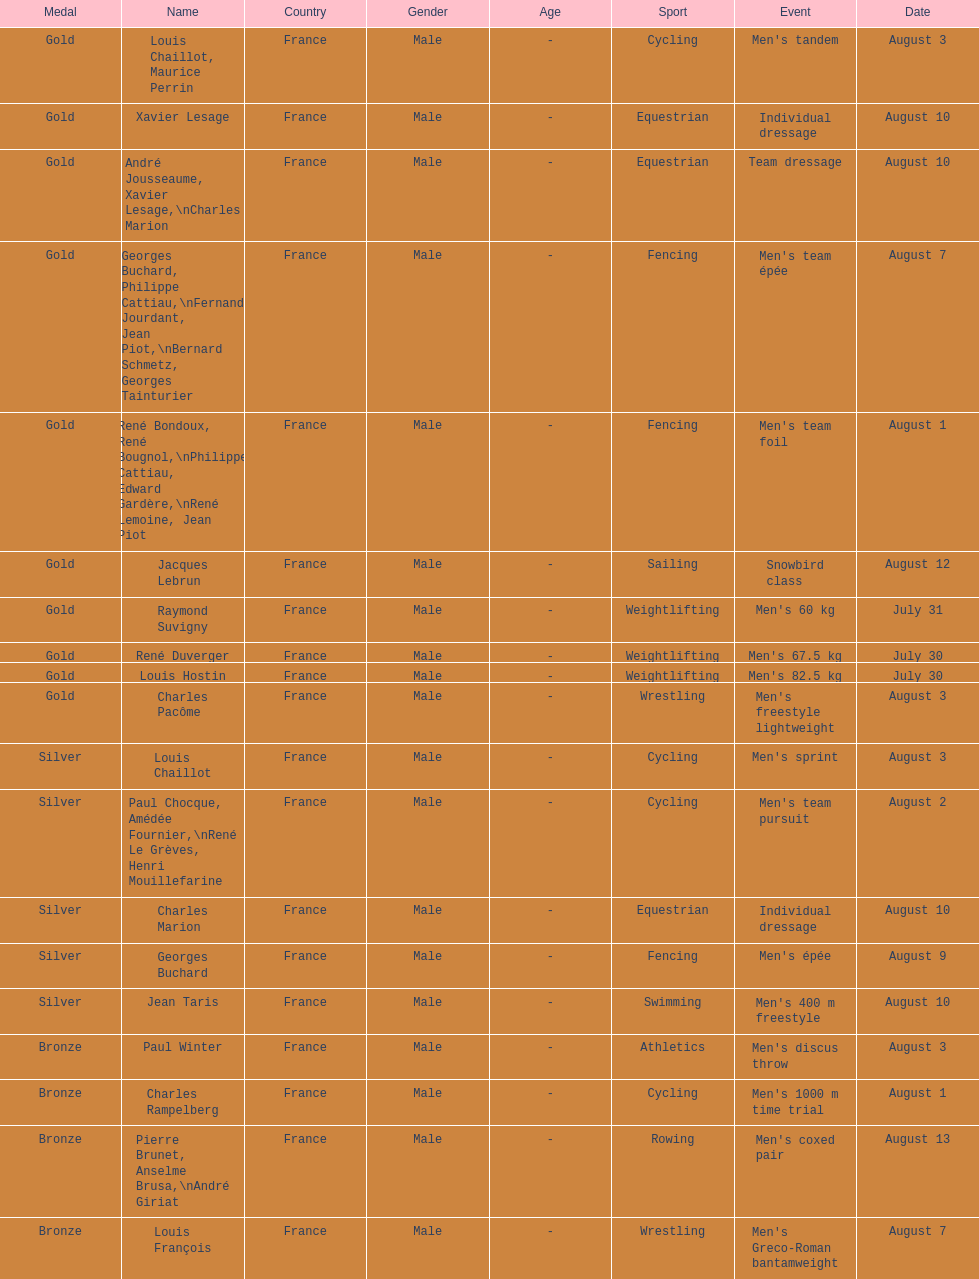What sport did louis challiot win the same medal as paul chocque in? Cycling. Parse the full table. {'header': ['Medal', 'Name', 'Country', 'Gender', 'Age', 'Sport', 'Event', 'Date'], 'rows': [['Gold', 'Louis Chaillot, Maurice Perrin', 'France', 'Male', '-', 'Cycling', "Men's tandem", 'August 3'], ['Gold', 'Xavier Lesage', 'France', 'Male', '-', 'Equestrian', 'Individual dressage', 'August 10'], ['Gold', 'André Jousseaume, Xavier Lesage,\\nCharles Marion', 'France', 'Male', '-', 'Equestrian', 'Team dressage', 'August 10'], ['Gold', 'Georges Buchard, Philippe Cattiau,\\nFernand Jourdant, Jean Piot,\\nBernard Schmetz, Georges Tainturier', 'France', 'Male', '-', 'Fencing', "Men's team épée", 'August 7'], ['Gold', 'René Bondoux, René Bougnol,\\nPhilippe Cattiau, Edward Gardère,\\nRené Lemoine, Jean Piot', 'France', 'Male', '-', 'Fencing', "Men's team foil", 'August 1'], ['Gold', 'Jacques Lebrun', 'France', 'Male', '-', 'Sailing', 'Snowbird class', 'August 12'], ['Gold', 'Raymond Suvigny', 'France', 'Male', '-', 'Weightlifting', "Men's 60 kg", 'July 31'], ['Gold', 'René Duverger', 'France', 'Male', '-', 'Weightlifting', "Men's 67.5 kg", 'July 30'], ['Gold', 'Louis Hostin', 'France', 'Male', '-', 'Weightlifting', "Men's 82.5 kg", 'July 30'], ['Gold', 'Charles Pacôme', 'France', 'Male', '-', 'Wrestling', "Men's freestyle lightweight", 'August 3'], ['Silver', 'Louis Chaillot', 'France', 'Male', '-', 'Cycling', "Men's sprint", 'August 3'], ['Silver', 'Paul Chocque, Amédée Fournier,\\nRené Le Grèves, Henri Mouillefarine', 'France', 'Male', '-', 'Cycling', "Men's team pursuit", 'August 2'], ['Silver', 'Charles Marion', 'France', 'Male', '-', 'Equestrian', 'Individual dressage', 'August 10'], ['Silver', 'Georges Buchard', 'France', 'Male', '-', 'Fencing', "Men's épée", 'August 9'], ['Silver', 'Jean Taris', 'France', 'Male', '-', 'Swimming', "Men's 400 m freestyle", 'August 10'], ['Bronze', 'Paul Winter', 'France', 'Male', '-', 'Athletics', "Men's discus throw", 'August 3'], ['Bronze', 'Charles Rampelberg', 'France', 'Male', '-', 'Cycling', "Men's 1000 m time trial", 'August 1'], ['Bronze', 'Pierre Brunet, Anselme Brusa,\\nAndré Giriat', 'France', 'Male', '-', 'Rowing', "Men's coxed pair", 'August 13'], ['Bronze', 'Louis François', 'France', 'Male', '-', 'Wrestling', "Men's Greco-Roman bantamweight", 'August 7']]} 